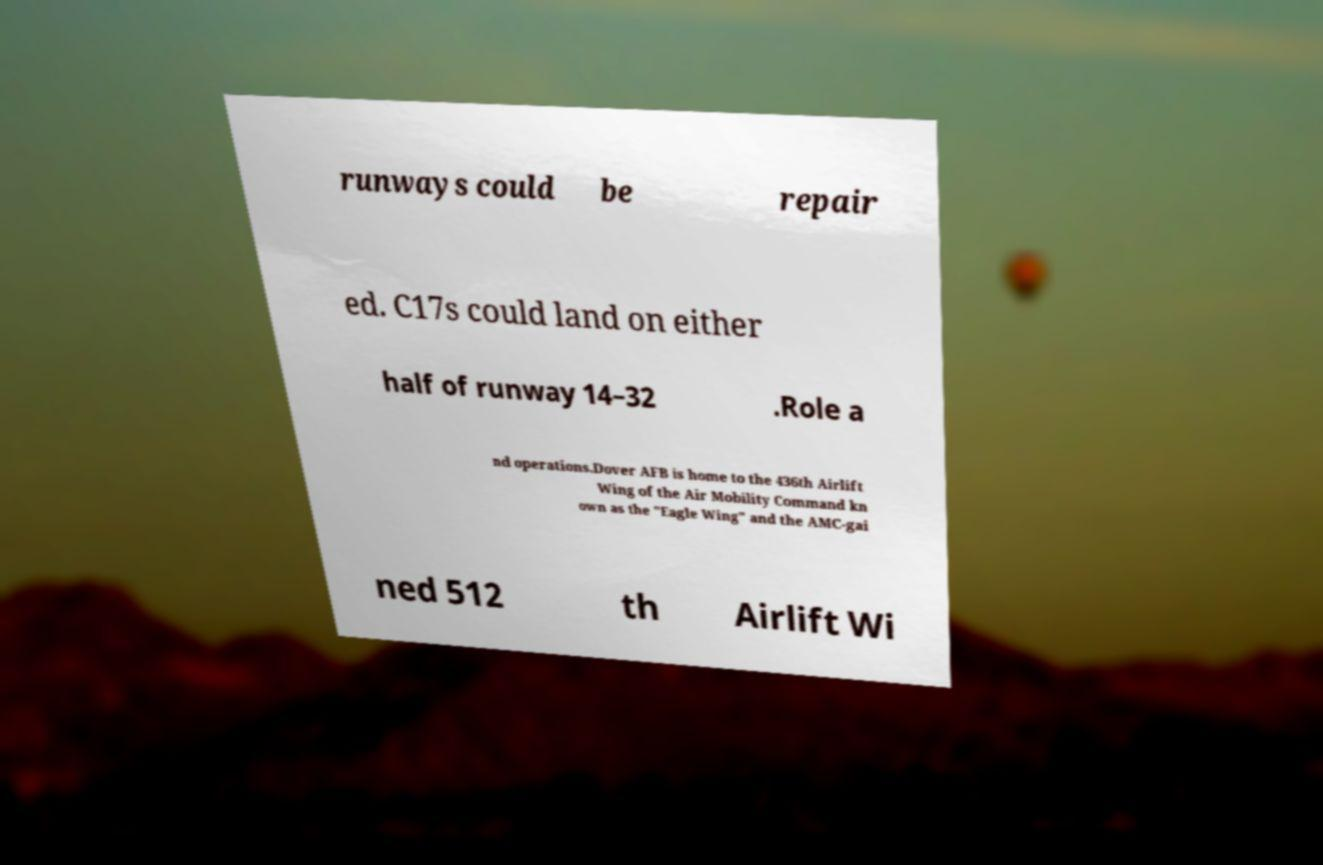Please identify and transcribe the text found in this image. runways could be repair ed. C17s could land on either half of runway 14–32 .Role a nd operations.Dover AFB is home to the 436th Airlift Wing of the Air Mobility Command kn own as the "Eagle Wing" and the AMC-gai ned 512 th Airlift Wi 